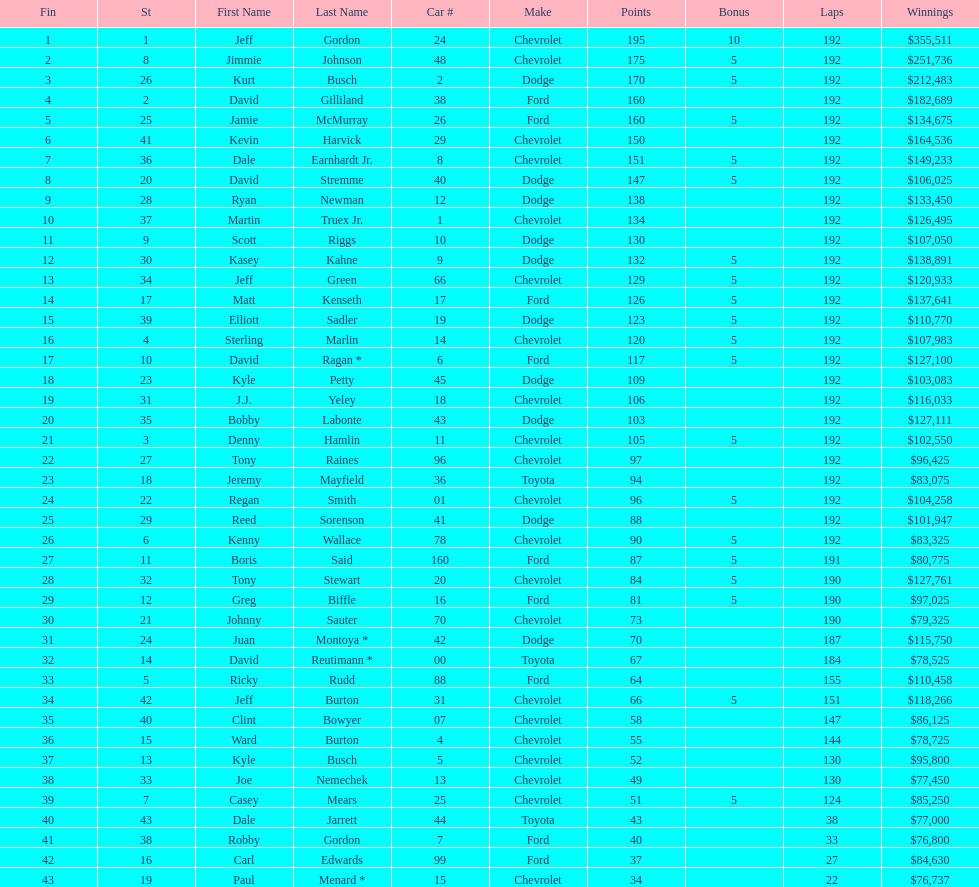I'm looking to parse the entire table for insights. Could you assist me with that? {'header': ['Fin', 'St', 'First Name', 'Last Name', 'Car #', 'Make', 'Points', 'Bonus', 'Laps', 'Winnings'], 'rows': [['1', '1', 'Jeff', 'Gordon', '24', 'Chevrolet', '195', '10', '192', '$355,511'], ['2', '8', 'Jimmie', 'Johnson', '48', 'Chevrolet', '175', '5', '192', '$251,736'], ['3', '26', 'Kurt', 'Busch', '2', 'Dodge', '170', '5', '192', '$212,483'], ['4', '2', 'David', 'Gilliland', '38', 'Ford', '160', '', '192', '$182,689'], ['5', '25', 'Jamie', 'McMurray', '26', 'Ford', '160', '5', '192', '$134,675'], ['6', '41', 'Kevin', 'Harvick', '29', 'Chevrolet', '150', '', '192', '$164,536'], ['7', '36', 'Dale', 'Earnhardt Jr.', '8', 'Chevrolet', '151', '5', '192', '$149,233'], ['8', '20', 'David', 'Stremme', '40', 'Dodge', '147', '5', '192', '$106,025'], ['9', '28', 'Ryan', 'Newman', '12', 'Dodge', '138', '', '192', '$133,450'], ['10', '37', 'Martin', 'Truex Jr.', '1', 'Chevrolet', '134', '', '192', '$126,495'], ['11', '9', 'Scott', 'Riggs', '10', 'Dodge', '130', '', '192', '$107,050'], ['12', '30', 'Kasey', 'Kahne', '9', 'Dodge', '132', '5', '192', '$138,891'], ['13', '34', 'Jeff', 'Green', '66', 'Chevrolet', '129', '5', '192', '$120,933'], ['14', '17', 'Matt', 'Kenseth', '17', 'Ford', '126', '5', '192', '$137,641'], ['15', '39', 'Elliott', 'Sadler', '19', 'Dodge', '123', '5', '192', '$110,770'], ['16', '4', 'Sterling', 'Marlin', '14', 'Chevrolet', '120', '5', '192', '$107,983'], ['17', '10', 'David', 'Ragan *', '6', 'Ford', '117', '5', '192', '$127,100'], ['18', '23', 'Kyle', 'Petty', '45', 'Dodge', '109', '', '192', '$103,083'], ['19', '31', 'J.J.', 'Yeley', '18', 'Chevrolet', '106', '', '192', '$116,033'], ['20', '35', 'Bobby', 'Labonte', '43', 'Dodge', '103', '', '192', '$127,111'], ['21', '3', 'Denny', 'Hamlin', '11', 'Chevrolet', '105', '5', '192', '$102,550'], ['22', '27', 'Tony', 'Raines', '96', 'Chevrolet', '97', '', '192', '$96,425'], ['23', '18', 'Jeremy', 'Mayfield', '36', 'Toyota', '94', '', '192', '$83,075'], ['24', '22', 'Regan', 'Smith', '01', 'Chevrolet', '96', '5', '192', '$104,258'], ['25', '29', 'Reed', 'Sorenson', '41', 'Dodge', '88', '', '192', '$101,947'], ['26', '6', 'Kenny', 'Wallace', '78', 'Chevrolet', '90', '5', '192', '$83,325'], ['27', '11', 'Boris', 'Said', '160', 'Ford', '87', '5', '191', '$80,775'], ['28', '32', 'Tony', 'Stewart', '20', 'Chevrolet', '84', '5', '190', '$127,761'], ['29', '12', 'Greg', 'Biffle', '16', 'Ford', '81', '5', '190', '$97,025'], ['30', '21', 'Johnny', 'Sauter', '70', 'Chevrolet', '73', '', '190', '$79,325'], ['31', '24', 'Juan', 'Montoya *', '42', 'Dodge', '70', '', '187', '$115,750'], ['32', '14', 'David', 'Reutimann *', '00', 'Toyota', '67', '', '184', '$78,525'], ['33', '5', 'Ricky', 'Rudd', '88', 'Ford', '64', '', '155', '$110,458'], ['34', '42', 'Jeff', 'Burton', '31', 'Chevrolet', '66', '5', '151', '$118,266'], ['35', '40', 'Clint', 'Bowyer', '07', 'Chevrolet', '58', '', '147', '$86,125'], ['36', '15', 'Ward', 'Burton', '4', 'Chevrolet', '55', '', '144', '$78,725'], ['37', '13', 'Kyle', 'Busch', '5', 'Chevrolet', '52', '', '130', '$95,800'], ['38', '33', 'Joe', 'Nemechek', '13', 'Chevrolet', '49', '', '130', '$77,450'], ['39', '7', 'Casey', 'Mears', '25', 'Chevrolet', '51', '5', '124', '$85,250'], ['40', '43', 'Dale', 'Jarrett', '44', 'Toyota', '43', '', '38', '$77,000'], ['41', '38', 'Robby', 'Gordon', '7', 'Ford', '40', '', '33', '$76,800'], ['42', '16', 'Carl', 'Edwards', '99', 'Ford', '37', '', '27', '$84,630'], ['43', '19', 'Paul', 'Menard *', '15', 'Chevrolet', '34', '', '22', '$76,737']]} What make did kurt busch drive? Dodge. 